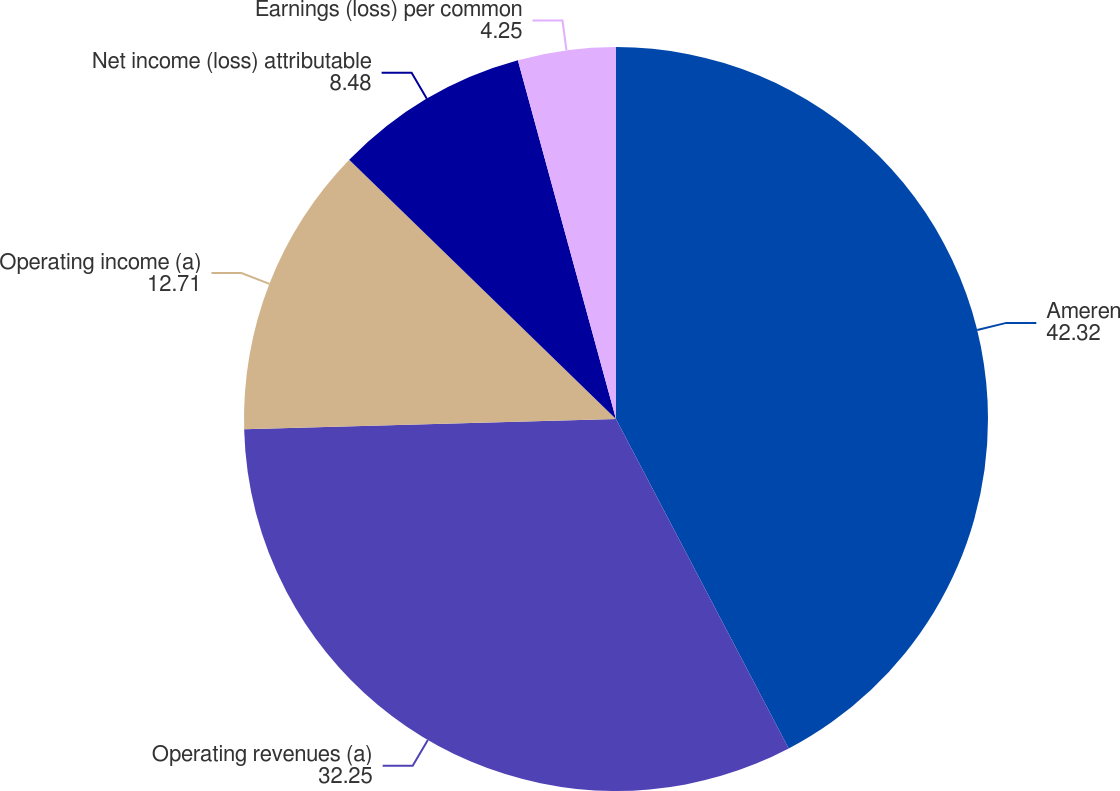Convert chart to OTSL. <chart><loc_0><loc_0><loc_500><loc_500><pie_chart><fcel>Ameren<fcel>Operating revenues (a)<fcel>Operating income (a)<fcel>Net income (loss) attributable<fcel>Earnings (loss) per common<nl><fcel>42.32%<fcel>32.25%<fcel>12.71%<fcel>8.48%<fcel>4.25%<nl></chart> 